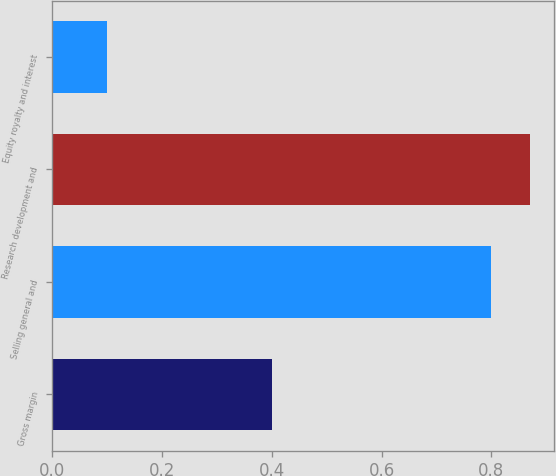<chart> <loc_0><loc_0><loc_500><loc_500><bar_chart><fcel>Gross margin<fcel>Selling general and<fcel>Research development and<fcel>Equity royalty and interest<nl><fcel>0.4<fcel>0.8<fcel>0.87<fcel>0.1<nl></chart> 